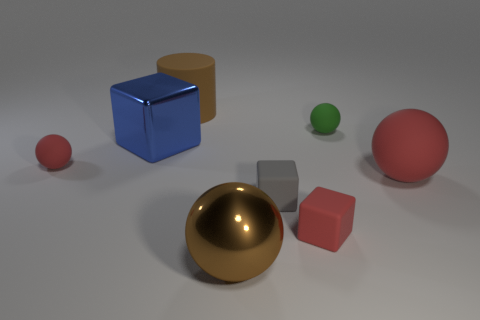Add 1 tiny spheres. How many objects exist? 9 Subtract all brown spheres. How many spheres are left? 3 Subtract all red blocks. How many red spheres are left? 2 Subtract 1 balls. How many balls are left? 3 Subtract all gray cubes. How many cubes are left? 2 Subtract all blocks. How many objects are left? 5 Subtract all blue cylinders. Subtract all gray spheres. How many cylinders are left? 1 Subtract all tiny gray rubber blocks. Subtract all brown balls. How many objects are left? 6 Add 5 red matte spheres. How many red matte spheres are left? 7 Add 3 big cyan shiny spheres. How many big cyan shiny spheres exist? 3 